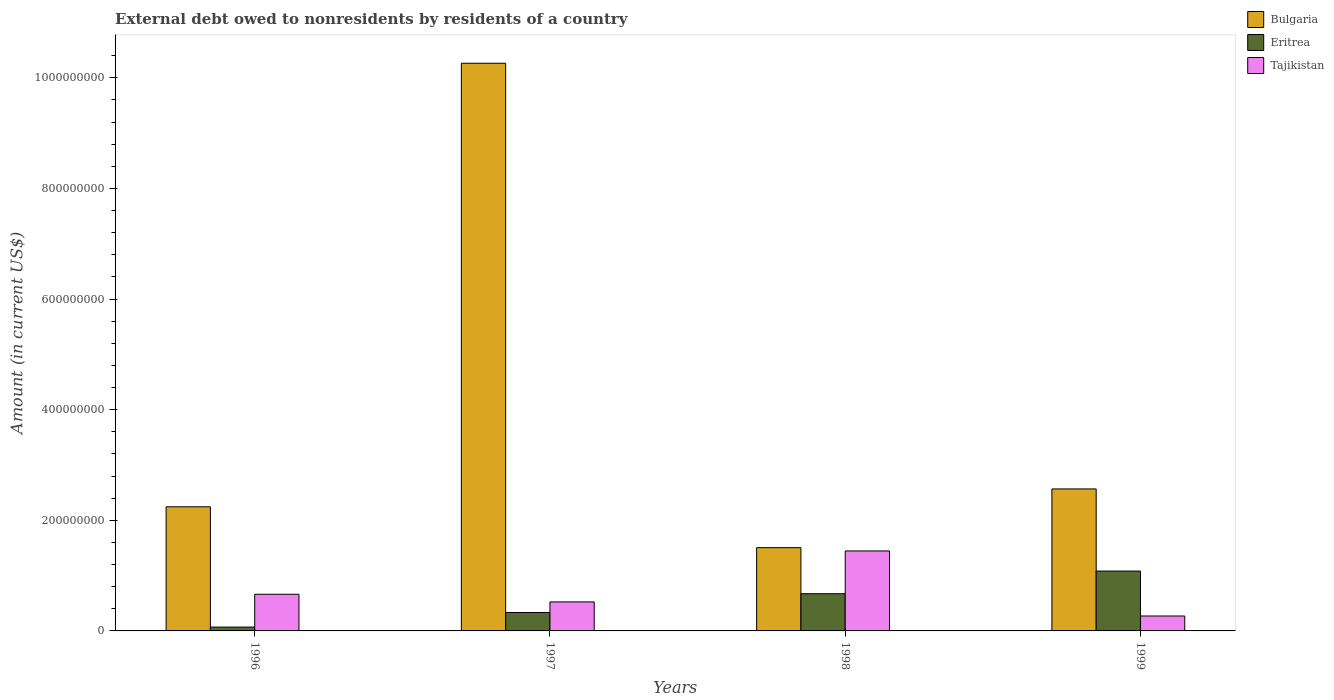How many different coloured bars are there?
Offer a very short reply. 3. How many groups of bars are there?
Make the answer very short. 4. Are the number of bars per tick equal to the number of legend labels?
Provide a succinct answer. Yes. Are the number of bars on each tick of the X-axis equal?
Keep it short and to the point. Yes. How many bars are there on the 2nd tick from the left?
Offer a very short reply. 3. What is the label of the 1st group of bars from the left?
Your answer should be compact. 1996. What is the external debt owed by residents in Tajikistan in 1998?
Keep it short and to the point. 1.45e+08. Across all years, what is the maximum external debt owed by residents in Bulgaria?
Keep it short and to the point. 1.03e+09. Across all years, what is the minimum external debt owed by residents in Tajikistan?
Give a very brief answer. 2.70e+07. In which year was the external debt owed by residents in Bulgaria maximum?
Give a very brief answer. 1997. In which year was the external debt owed by residents in Tajikistan minimum?
Your response must be concise. 1999. What is the total external debt owed by residents in Tajikistan in the graph?
Offer a very short reply. 2.90e+08. What is the difference between the external debt owed by residents in Tajikistan in 1996 and that in 1999?
Ensure brevity in your answer.  3.93e+07. What is the difference between the external debt owed by residents in Bulgaria in 1998 and the external debt owed by residents in Eritrea in 1999?
Keep it short and to the point. 4.23e+07. What is the average external debt owed by residents in Bulgaria per year?
Provide a succinct answer. 4.15e+08. In the year 1996, what is the difference between the external debt owed by residents in Eritrea and external debt owed by residents in Bulgaria?
Your response must be concise. -2.17e+08. What is the ratio of the external debt owed by residents in Tajikistan in 1996 to that in 1997?
Your answer should be very brief. 1.26. What is the difference between the highest and the second highest external debt owed by residents in Eritrea?
Ensure brevity in your answer.  4.10e+07. What is the difference between the highest and the lowest external debt owed by residents in Eritrea?
Keep it short and to the point. 1.01e+08. Is the sum of the external debt owed by residents in Tajikistan in 1998 and 1999 greater than the maximum external debt owed by residents in Eritrea across all years?
Give a very brief answer. Yes. What does the 1st bar from the right in 1999 represents?
Ensure brevity in your answer.  Tajikistan. How many bars are there?
Make the answer very short. 12. Does the graph contain grids?
Make the answer very short. No. Where does the legend appear in the graph?
Ensure brevity in your answer.  Top right. How many legend labels are there?
Ensure brevity in your answer.  3. How are the legend labels stacked?
Make the answer very short. Vertical. What is the title of the graph?
Provide a short and direct response. External debt owed to nonresidents by residents of a country. What is the label or title of the X-axis?
Provide a succinct answer. Years. What is the label or title of the Y-axis?
Ensure brevity in your answer.  Amount (in current US$). What is the Amount (in current US$) in Bulgaria in 1996?
Ensure brevity in your answer.  2.24e+08. What is the Amount (in current US$) of Eritrea in 1996?
Make the answer very short. 6.93e+06. What is the Amount (in current US$) of Tajikistan in 1996?
Your response must be concise. 6.63e+07. What is the Amount (in current US$) of Bulgaria in 1997?
Your answer should be very brief. 1.03e+09. What is the Amount (in current US$) of Eritrea in 1997?
Ensure brevity in your answer.  3.33e+07. What is the Amount (in current US$) in Tajikistan in 1997?
Your answer should be compact. 5.24e+07. What is the Amount (in current US$) of Bulgaria in 1998?
Your answer should be very brief. 1.51e+08. What is the Amount (in current US$) of Eritrea in 1998?
Offer a very short reply. 6.73e+07. What is the Amount (in current US$) of Tajikistan in 1998?
Provide a short and direct response. 1.45e+08. What is the Amount (in current US$) of Bulgaria in 1999?
Keep it short and to the point. 2.57e+08. What is the Amount (in current US$) in Eritrea in 1999?
Provide a succinct answer. 1.08e+08. What is the Amount (in current US$) in Tajikistan in 1999?
Your answer should be very brief. 2.70e+07. Across all years, what is the maximum Amount (in current US$) of Bulgaria?
Offer a very short reply. 1.03e+09. Across all years, what is the maximum Amount (in current US$) of Eritrea?
Ensure brevity in your answer.  1.08e+08. Across all years, what is the maximum Amount (in current US$) of Tajikistan?
Ensure brevity in your answer.  1.45e+08. Across all years, what is the minimum Amount (in current US$) of Bulgaria?
Your response must be concise. 1.51e+08. Across all years, what is the minimum Amount (in current US$) of Eritrea?
Your response must be concise. 6.93e+06. Across all years, what is the minimum Amount (in current US$) in Tajikistan?
Offer a very short reply. 2.70e+07. What is the total Amount (in current US$) of Bulgaria in the graph?
Provide a short and direct response. 1.66e+09. What is the total Amount (in current US$) in Eritrea in the graph?
Make the answer very short. 2.16e+08. What is the total Amount (in current US$) of Tajikistan in the graph?
Offer a very short reply. 2.90e+08. What is the difference between the Amount (in current US$) in Bulgaria in 1996 and that in 1997?
Your answer should be compact. -8.02e+08. What is the difference between the Amount (in current US$) in Eritrea in 1996 and that in 1997?
Provide a succinct answer. -2.64e+07. What is the difference between the Amount (in current US$) of Tajikistan in 1996 and that in 1997?
Provide a short and direct response. 1.38e+07. What is the difference between the Amount (in current US$) of Bulgaria in 1996 and that in 1998?
Provide a succinct answer. 7.39e+07. What is the difference between the Amount (in current US$) in Eritrea in 1996 and that in 1998?
Give a very brief answer. -6.03e+07. What is the difference between the Amount (in current US$) of Tajikistan in 1996 and that in 1998?
Provide a succinct answer. -7.83e+07. What is the difference between the Amount (in current US$) of Bulgaria in 1996 and that in 1999?
Make the answer very short. -3.23e+07. What is the difference between the Amount (in current US$) of Eritrea in 1996 and that in 1999?
Your answer should be compact. -1.01e+08. What is the difference between the Amount (in current US$) of Tajikistan in 1996 and that in 1999?
Offer a very short reply. 3.93e+07. What is the difference between the Amount (in current US$) of Bulgaria in 1997 and that in 1998?
Ensure brevity in your answer.  8.76e+08. What is the difference between the Amount (in current US$) of Eritrea in 1997 and that in 1998?
Ensure brevity in your answer.  -3.40e+07. What is the difference between the Amount (in current US$) in Tajikistan in 1997 and that in 1998?
Offer a very short reply. -9.22e+07. What is the difference between the Amount (in current US$) of Bulgaria in 1997 and that in 1999?
Make the answer very short. 7.70e+08. What is the difference between the Amount (in current US$) in Eritrea in 1997 and that in 1999?
Ensure brevity in your answer.  -7.49e+07. What is the difference between the Amount (in current US$) in Tajikistan in 1997 and that in 1999?
Keep it short and to the point. 2.54e+07. What is the difference between the Amount (in current US$) in Bulgaria in 1998 and that in 1999?
Your answer should be compact. -1.06e+08. What is the difference between the Amount (in current US$) in Eritrea in 1998 and that in 1999?
Your answer should be very brief. -4.10e+07. What is the difference between the Amount (in current US$) in Tajikistan in 1998 and that in 1999?
Your response must be concise. 1.18e+08. What is the difference between the Amount (in current US$) of Bulgaria in 1996 and the Amount (in current US$) of Eritrea in 1997?
Your response must be concise. 1.91e+08. What is the difference between the Amount (in current US$) in Bulgaria in 1996 and the Amount (in current US$) in Tajikistan in 1997?
Give a very brief answer. 1.72e+08. What is the difference between the Amount (in current US$) of Eritrea in 1996 and the Amount (in current US$) of Tajikistan in 1997?
Keep it short and to the point. -4.55e+07. What is the difference between the Amount (in current US$) of Bulgaria in 1996 and the Amount (in current US$) of Eritrea in 1998?
Your answer should be compact. 1.57e+08. What is the difference between the Amount (in current US$) in Bulgaria in 1996 and the Amount (in current US$) in Tajikistan in 1998?
Ensure brevity in your answer.  7.98e+07. What is the difference between the Amount (in current US$) in Eritrea in 1996 and the Amount (in current US$) in Tajikistan in 1998?
Offer a terse response. -1.38e+08. What is the difference between the Amount (in current US$) of Bulgaria in 1996 and the Amount (in current US$) of Eritrea in 1999?
Offer a very short reply. 1.16e+08. What is the difference between the Amount (in current US$) in Bulgaria in 1996 and the Amount (in current US$) in Tajikistan in 1999?
Your answer should be very brief. 1.97e+08. What is the difference between the Amount (in current US$) in Eritrea in 1996 and the Amount (in current US$) in Tajikistan in 1999?
Provide a short and direct response. -2.01e+07. What is the difference between the Amount (in current US$) of Bulgaria in 1997 and the Amount (in current US$) of Eritrea in 1998?
Your answer should be very brief. 9.59e+08. What is the difference between the Amount (in current US$) in Bulgaria in 1997 and the Amount (in current US$) in Tajikistan in 1998?
Make the answer very short. 8.82e+08. What is the difference between the Amount (in current US$) in Eritrea in 1997 and the Amount (in current US$) in Tajikistan in 1998?
Keep it short and to the point. -1.11e+08. What is the difference between the Amount (in current US$) of Bulgaria in 1997 and the Amount (in current US$) of Eritrea in 1999?
Your answer should be compact. 9.18e+08. What is the difference between the Amount (in current US$) in Bulgaria in 1997 and the Amount (in current US$) in Tajikistan in 1999?
Make the answer very short. 9.99e+08. What is the difference between the Amount (in current US$) of Eritrea in 1997 and the Amount (in current US$) of Tajikistan in 1999?
Ensure brevity in your answer.  6.33e+06. What is the difference between the Amount (in current US$) of Bulgaria in 1998 and the Amount (in current US$) of Eritrea in 1999?
Your response must be concise. 4.23e+07. What is the difference between the Amount (in current US$) in Bulgaria in 1998 and the Amount (in current US$) in Tajikistan in 1999?
Provide a succinct answer. 1.24e+08. What is the difference between the Amount (in current US$) of Eritrea in 1998 and the Amount (in current US$) of Tajikistan in 1999?
Ensure brevity in your answer.  4.03e+07. What is the average Amount (in current US$) of Bulgaria per year?
Offer a very short reply. 4.15e+08. What is the average Amount (in current US$) of Eritrea per year?
Your answer should be compact. 5.39e+07. What is the average Amount (in current US$) in Tajikistan per year?
Provide a short and direct response. 7.26e+07. In the year 1996, what is the difference between the Amount (in current US$) in Bulgaria and Amount (in current US$) in Eritrea?
Your response must be concise. 2.17e+08. In the year 1996, what is the difference between the Amount (in current US$) in Bulgaria and Amount (in current US$) in Tajikistan?
Your answer should be compact. 1.58e+08. In the year 1996, what is the difference between the Amount (in current US$) in Eritrea and Amount (in current US$) in Tajikistan?
Ensure brevity in your answer.  -5.93e+07. In the year 1997, what is the difference between the Amount (in current US$) in Bulgaria and Amount (in current US$) in Eritrea?
Keep it short and to the point. 9.93e+08. In the year 1997, what is the difference between the Amount (in current US$) of Bulgaria and Amount (in current US$) of Tajikistan?
Provide a short and direct response. 9.74e+08. In the year 1997, what is the difference between the Amount (in current US$) in Eritrea and Amount (in current US$) in Tajikistan?
Ensure brevity in your answer.  -1.91e+07. In the year 1998, what is the difference between the Amount (in current US$) of Bulgaria and Amount (in current US$) of Eritrea?
Offer a very short reply. 8.33e+07. In the year 1998, what is the difference between the Amount (in current US$) in Bulgaria and Amount (in current US$) in Tajikistan?
Your response must be concise. 5.97e+06. In the year 1998, what is the difference between the Amount (in current US$) of Eritrea and Amount (in current US$) of Tajikistan?
Ensure brevity in your answer.  -7.73e+07. In the year 1999, what is the difference between the Amount (in current US$) of Bulgaria and Amount (in current US$) of Eritrea?
Your answer should be compact. 1.48e+08. In the year 1999, what is the difference between the Amount (in current US$) in Bulgaria and Amount (in current US$) in Tajikistan?
Offer a very short reply. 2.30e+08. In the year 1999, what is the difference between the Amount (in current US$) in Eritrea and Amount (in current US$) in Tajikistan?
Give a very brief answer. 8.13e+07. What is the ratio of the Amount (in current US$) of Bulgaria in 1996 to that in 1997?
Offer a very short reply. 0.22. What is the ratio of the Amount (in current US$) of Eritrea in 1996 to that in 1997?
Make the answer very short. 0.21. What is the ratio of the Amount (in current US$) in Tajikistan in 1996 to that in 1997?
Keep it short and to the point. 1.26. What is the ratio of the Amount (in current US$) of Bulgaria in 1996 to that in 1998?
Offer a terse response. 1.49. What is the ratio of the Amount (in current US$) in Eritrea in 1996 to that in 1998?
Offer a terse response. 0.1. What is the ratio of the Amount (in current US$) of Tajikistan in 1996 to that in 1998?
Offer a terse response. 0.46. What is the ratio of the Amount (in current US$) of Bulgaria in 1996 to that in 1999?
Provide a short and direct response. 0.87. What is the ratio of the Amount (in current US$) of Eritrea in 1996 to that in 1999?
Ensure brevity in your answer.  0.06. What is the ratio of the Amount (in current US$) of Tajikistan in 1996 to that in 1999?
Make the answer very short. 2.46. What is the ratio of the Amount (in current US$) of Bulgaria in 1997 to that in 1998?
Provide a succinct answer. 6.82. What is the ratio of the Amount (in current US$) in Eritrea in 1997 to that in 1998?
Ensure brevity in your answer.  0.5. What is the ratio of the Amount (in current US$) of Tajikistan in 1997 to that in 1998?
Give a very brief answer. 0.36. What is the ratio of the Amount (in current US$) of Bulgaria in 1997 to that in 1999?
Your answer should be very brief. 4. What is the ratio of the Amount (in current US$) in Eritrea in 1997 to that in 1999?
Keep it short and to the point. 0.31. What is the ratio of the Amount (in current US$) in Tajikistan in 1997 to that in 1999?
Your answer should be compact. 1.94. What is the ratio of the Amount (in current US$) in Bulgaria in 1998 to that in 1999?
Ensure brevity in your answer.  0.59. What is the ratio of the Amount (in current US$) in Eritrea in 1998 to that in 1999?
Your answer should be very brief. 0.62. What is the ratio of the Amount (in current US$) in Tajikistan in 1998 to that in 1999?
Make the answer very short. 5.36. What is the difference between the highest and the second highest Amount (in current US$) in Bulgaria?
Provide a short and direct response. 7.70e+08. What is the difference between the highest and the second highest Amount (in current US$) of Eritrea?
Offer a very short reply. 4.10e+07. What is the difference between the highest and the second highest Amount (in current US$) in Tajikistan?
Give a very brief answer. 7.83e+07. What is the difference between the highest and the lowest Amount (in current US$) in Bulgaria?
Offer a terse response. 8.76e+08. What is the difference between the highest and the lowest Amount (in current US$) in Eritrea?
Ensure brevity in your answer.  1.01e+08. What is the difference between the highest and the lowest Amount (in current US$) of Tajikistan?
Give a very brief answer. 1.18e+08. 